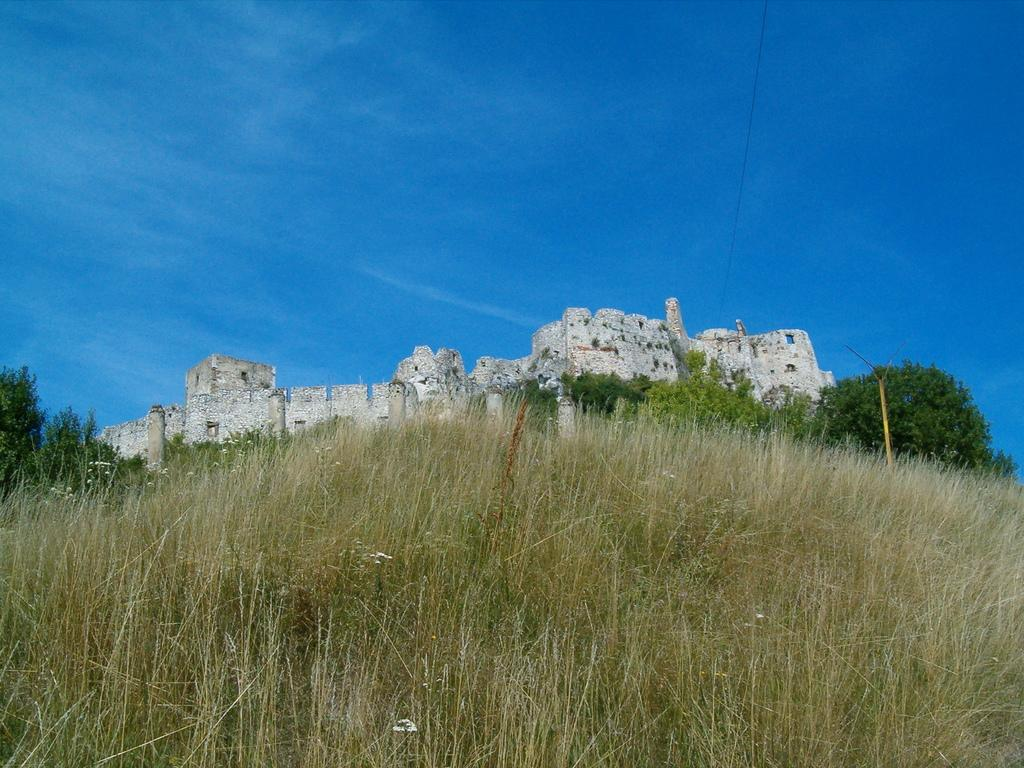What type of vegetation can be seen in the image? There is grass in the image. What type of structure is present in the image? There is a stone fort in the image. What other natural elements can be seen in the image? There are trees in the image. What is the color of the sky in the background of the image? The sky is blue in the background of the image. Where is the cactus located in the image? There is no cactus present in the image. What type of watercraft can be seen in the harbor in the image? There is no harbor or watercraft present in the image. 